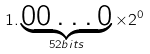<formula> <loc_0><loc_0><loc_500><loc_500>1 . \underbrace { 0 0 \dots 0 } _ { 5 2 b i t s } \times 2 ^ { 0 }</formula> 